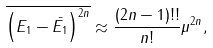<formula> <loc_0><loc_0><loc_500><loc_500>\overline { \left ( E _ { 1 } - \bar { E _ { 1 } } \right ) ^ { 2 n } } \approx \frac { ( 2 n - 1 ) ! ! } { n ! } \mu ^ { 2 n } ,</formula> 